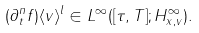<formula> <loc_0><loc_0><loc_500><loc_500>( \partial _ { t } ^ { n } f ) \langle v \rangle ^ { l } \in L ^ { \infty } ( [ \tau , T ] ; H ^ { \infty } _ { x , v } ) .</formula> 